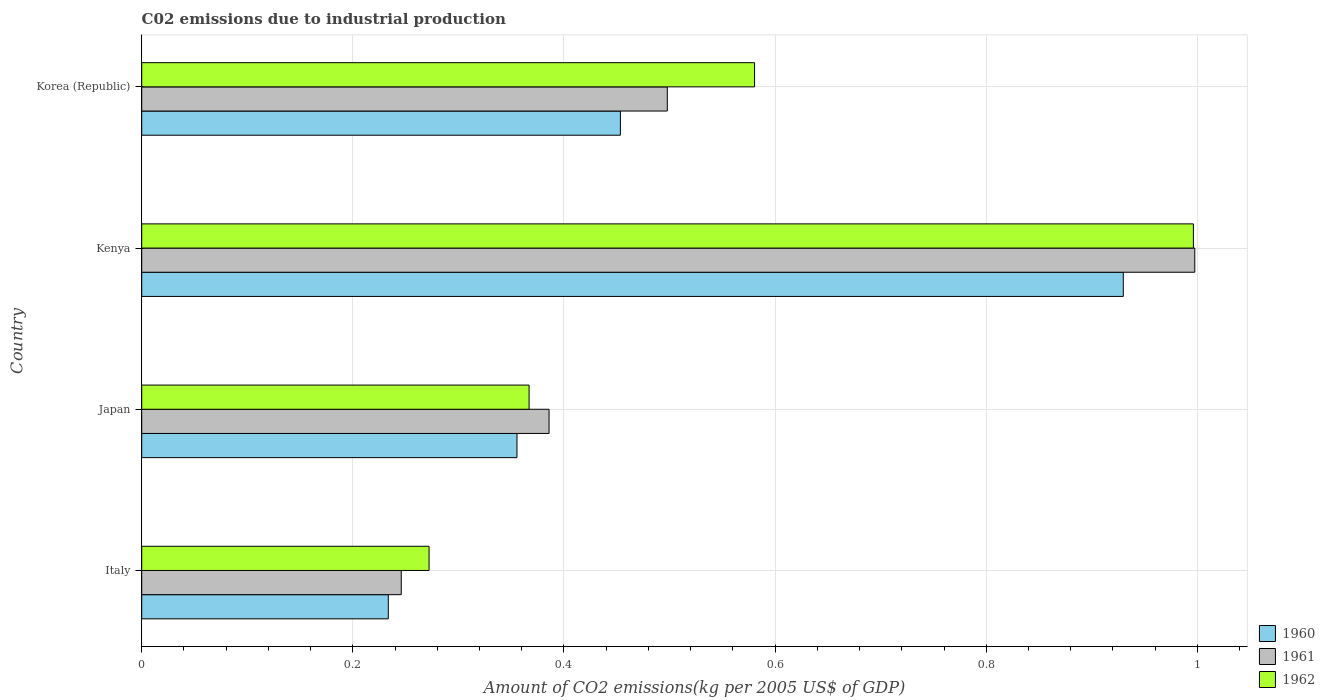How many different coloured bars are there?
Ensure brevity in your answer.  3. What is the label of the 2nd group of bars from the top?
Keep it short and to the point. Kenya. In how many cases, is the number of bars for a given country not equal to the number of legend labels?
Your answer should be compact. 0. What is the amount of CO2 emitted due to industrial production in 1961 in Italy?
Keep it short and to the point. 0.25. Across all countries, what is the maximum amount of CO2 emitted due to industrial production in 1961?
Your answer should be compact. 1. Across all countries, what is the minimum amount of CO2 emitted due to industrial production in 1961?
Offer a very short reply. 0.25. In which country was the amount of CO2 emitted due to industrial production in 1961 maximum?
Keep it short and to the point. Kenya. What is the total amount of CO2 emitted due to industrial production in 1960 in the graph?
Give a very brief answer. 1.97. What is the difference between the amount of CO2 emitted due to industrial production in 1960 in Italy and that in Kenya?
Keep it short and to the point. -0.7. What is the difference between the amount of CO2 emitted due to industrial production in 1962 in Japan and the amount of CO2 emitted due to industrial production in 1960 in Korea (Republic)?
Provide a succinct answer. -0.09. What is the average amount of CO2 emitted due to industrial production in 1961 per country?
Offer a terse response. 0.53. What is the difference between the amount of CO2 emitted due to industrial production in 1962 and amount of CO2 emitted due to industrial production in 1960 in Kenya?
Provide a succinct answer. 0.07. What is the ratio of the amount of CO2 emitted due to industrial production in 1960 in Italy to that in Kenya?
Keep it short and to the point. 0.25. What is the difference between the highest and the second highest amount of CO2 emitted due to industrial production in 1961?
Your response must be concise. 0.5. What is the difference between the highest and the lowest amount of CO2 emitted due to industrial production in 1961?
Ensure brevity in your answer.  0.75. Is the sum of the amount of CO2 emitted due to industrial production in 1960 in Italy and Kenya greater than the maximum amount of CO2 emitted due to industrial production in 1961 across all countries?
Your answer should be compact. Yes. What does the 1st bar from the top in Japan represents?
Make the answer very short. 1962. What does the 2nd bar from the bottom in Japan represents?
Make the answer very short. 1961. Is it the case that in every country, the sum of the amount of CO2 emitted due to industrial production in 1960 and amount of CO2 emitted due to industrial production in 1962 is greater than the amount of CO2 emitted due to industrial production in 1961?
Your response must be concise. Yes. How many countries are there in the graph?
Provide a short and direct response. 4. What is the difference between two consecutive major ticks on the X-axis?
Ensure brevity in your answer.  0.2. Does the graph contain any zero values?
Offer a terse response. No. Does the graph contain grids?
Provide a succinct answer. Yes. What is the title of the graph?
Provide a succinct answer. C02 emissions due to industrial production. Does "1988" appear as one of the legend labels in the graph?
Ensure brevity in your answer.  No. What is the label or title of the X-axis?
Provide a succinct answer. Amount of CO2 emissions(kg per 2005 US$ of GDP). What is the label or title of the Y-axis?
Make the answer very short. Country. What is the Amount of CO2 emissions(kg per 2005 US$ of GDP) in 1960 in Italy?
Keep it short and to the point. 0.23. What is the Amount of CO2 emissions(kg per 2005 US$ of GDP) in 1961 in Italy?
Make the answer very short. 0.25. What is the Amount of CO2 emissions(kg per 2005 US$ of GDP) of 1962 in Italy?
Provide a short and direct response. 0.27. What is the Amount of CO2 emissions(kg per 2005 US$ of GDP) of 1960 in Japan?
Provide a succinct answer. 0.36. What is the Amount of CO2 emissions(kg per 2005 US$ of GDP) in 1961 in Japan?
Make the answer very short. 0.39. What is the Amount of CO2 emissions(kg per 2005 US$ of GDP) of 1962 in Japan?
Offer a terse response. 0.37. What is the Amount of CO2 emissions(kg per 2005 US$ of GDP) in 1960 in Kenya?
Provide a short and direct response. 0.93. What is the Amount of CO2 emissions(kg per 2005 US$ of GDP) in 1961 in Kenya?
Provide a succinct answer. 1. What is the Amount of CO2 emissions(kg per 2005 US$ of GDP) in 1962 in Kenya?
Offer a very short reply. 1. What is the Amount of CO2 emissions(kg per 2005 US$ of GDP) of 1960 in Korea (Republic)?
Ensure brevity in your answer.  0.45. What is the Amount of CO2 emissions(kg per 2005 US$ of GDP) of 1961 in Korea (Republic)?
Your response must be concise. 0.5. What is the Amount of CO2 emissions(kg per 2005 US$ of GDP) of 1962 in Korea (Republic)?
Keep it short and to the point. 0.58. Across all countries, what is the maximum Amount of CO2 emissions(kg per 2005 US$ of GDP) of 1960?
Give a very brief answer. 0.93. Across all countries, what is the maximum Amount of CO2 emissions(kg per 2005 US$ of GDP) in 1961?
Your answer should be compact. 1. Across all countries, what is the maximum Amount of CO2 emissions(kg per 2005 US$ of GDP) in 1962?
Offer a very short reply. 1. Across all countries, what is the minimum Amount of CO2 emissions(kg per 2005 US$ of GDP) in 1960?
Your answer should be compact. 0.23. Across all countries, what is the minimum Amount of CO2 emissions(kg per 2005 US$ of GDP) of 1961?
Give a very brief answer. 0.25. Across all countries, what is the minimum Amount of CO2 emissions(kg per 2005 US$ of GDP) in 1962?
Your answer should be very brief. 0.27. What is the total Amount of CO2 emissions(kg per 2005 US$ of GDP) of 1960 in the graph?
Provide a short and direct response. 1.97. What is the total Amount of CO2 emissions(kg per 2005 US$ of GDP) in 1961 in the graph?
Make the answer very short. 2.13. What is the total Amount of CO2 emissions(kg per 2005 US$ of GDP) of 1962 in the graph?
Your response must be concise. 2.22. What is the difference between the Amount of CO2 emissions(kg per 2005 US$ of GDP) of 1960 in Italy and that in Japan?
Give a very brief answer. -0.12. What is the difference between the Amount of CO2 emissions(kg per 2005 US$ of GDP) of 1961 in Italy and that in Japan?
Your response must be concise. -0.14. What is the difference between the Amount of CO2 emissions(kg per 2005 US$ of GDP) in 1962 in Italy and that in Japan?
Make the answer very short. -0.09. What is the difference between the Amount of CO2 emissions(kg per 2005 US$ of GDP) of 1960 in Italy and that in Kenya?
Provide a succinct answer. -0.7. What is the difference between the Amount of CO2 emissions(kg per 2005 US$ of GDP) in 1961 in Italy and that in Kenya?
Offer a very short reply. -0.75. What is the difference between the Amount of CO2 emissions(kg per 2005 US$ of GDP) in 1962 in Italy and that in Kenya?
Your response must be concise. -0.72. What is the difference between the Amount of CO2 emissions(kg per 2005 US$ of GDP) of 1960 in Italy and that in Korea (Republic)?
Provide a succinct answer. -0.22. What is the difference between the Amount of CO2 emissions(kg per 2005 US$ of GDP) of 1961 in Italy and that in Korea (Republic)?
Keep it short and to the point. -0.25. What is the difference between the Amount of CO2 emissions(kg per 2005 US$ of GDP) of 1962 in Italy and that in Korea (Republic)?
Offer a very short reply. -0.31. What is the difference between the Amount of CO2 emissions(kg per 2005 US$ of GDP) in 1960 in Japan and that in Kenya?
Make the answer very short. -0.57. What is the difference between the Amount of CO2 emissions(kg per 2005 US$ of GDP) of 1961 in Japan and that in Kenya?
Your answer should be compact. -0.61. What is the difference between the Amount of CO2 emissions(kg per 2005 US$ of GDP) in 1962 in Japan and that in Kenya?
Your answer should be compact. -0.63. What is the difference between the Amount of CO2 emissions(kg per 2005 US$ of GDP) in 1960 in Japan and that in Korea (Republic)?
Make the answer very short. -0.1. What is the difference between the Amount of CO2 emissions(kg per 2005 US$ of GDP) in 1961 in Japan and that in Korea (Republic)?
Your answer should be very brief. -0.11. What is the difference between the Amount of CO2 emissions(kg per 2005 US$ of GDP) in 1962 in Japan and that in Korea (Republic)?
Provide a short and direct response. -0.21. What is the difference between the Amount of CO2 emissions(kg per 2005 US$ of GDP) of 1960 in Kenya and that in Korea (Republic)?
Your answer should be compact. 0.48. What is the difference between the Amount of CO2 emissions(kg per 2005 US$ of GDP) of 1961 in Kenya and that in Korea (Republic)?
Your response must be concise. 0.5. What is the difference between the Amount of CO2 emissions(kg per 2005 US$ of GDP) in 1962 in Kenya and that in Korea (Republic)?
Provide a succinct answer. 0.42. What is the difference between the Amount of CO2 emissions(kg per 2005 US$ of GDP) in 1960 in Italy and the Amount of CO2 emissions(kg per 2005 US$ of GDP) in 1961 in Japan?
Keep it short and to the point. -0.15. What is the difference between the Amount of CO2 emissions(kg per 2005 US$ of GDP) in 1960 in Italy and the Amount of CO2 emissions(kg per 2005 US$ of GDP) in 1962 in Japan?
Make the answer very short. -0.13. What is the difference between the Amount of CO2 emissions(kg per 2005 US$ of GDP) in 1961 in Italy and the Amount of CO2 emissions(kg per 2005 US$ of GDP) in 1962 in Japan?
Offer a terse response. -0.12. What is the difference between the Amount of CO2 emissions(kg per 2005 US$ of GDP) in 1960 in Italy and the Amount of CO2 emissions(kg per 2005 US$ of GDP) in 1961 in Kenya?
Your answer should be compact. -0.76. What is the difference between the Amount of CO2 emissions(kg per 2005 US$ of GDP) in 1960 in Italy and the Amount of CO2 emissions(kg per 2005 US$ of GDP) in 1962 in Kenya?
Your response must be concise. -0.76. What is the difference between the Amount of CO2 emissions(kg per 2005 US$ of GDP) in 1961 in Italy and the Amount of CO2 emissions(kg per 2005 US$ of GDP) in 1962 in Kenya?
Give a very brief answer. -0.75. What is the difference between the Amount of CO2 emissions(kg per 2005 US$ of GDP) of 1960 in Italy and the Amount of CO2 emissions(kg per 2005 US$ of GDP) of 1961 in Korea (Republic)?
Offer a very short reply. -0.26. What is the difference between the Amount of CO2 emissions(kg per 2005 US$ of GDP) in 1960 in Italy and the Amount of CO2 emissions(kg per 2005 US$ of GDP) in 1962 in Korea (Republic)?
Provide a succinct answer. -0.35. What is the difference between the Amount of CO2 emissions(kg per 2005 US$ of GDP) in 1961 in Italy and the Amount of CO2 emissions(kg per 2005 US$ of GDP) in 1962 in Korea (Republic)?
Provide a succinct answer. -0.33. What is the difference between the Amount of CO2 emissions(kg per 2005 US$ of GDP) in 1960 in Japan and the Amount of CO2 emissions(kg per 2005 US$ of GDP) in 1961 in Kenya?
Keep it short and to the point. -0.64. What is the difference between the Amount of CO2 emissions(kg per 2005 US$ of GDP) of 1960 in Japan and the Amount of CO2 emissions(kg per 2005 US$ of GDP) of 1962 in Kenya?
Your response must be concise. -0.64. What is the difference between the Amount of CO2 emissions(kg per 2005 US$ of GDP) in 1961 in Japan and the Amount of CO2 emissions(kg per 2005 US$ of GDP) in 1962 in Kenya?
Provide a short and direct response. -0.61. What is the difference between the Amount of CO2 emissions(kg per 2005 US$ of GDP) of 1960 in Japan and the Amount of CO2 emissions(kg per 2005 US$ of GDP) of 1961 in Korea (Republic)?
Keep it short and to the point. -0.14. What is the difference between the Amount of CO2 emissions(kg per 2005 US$ of GDP) in 1960 in Japan and the Amount of CO2 emissions(kg per 2005 US$ of GDP) in 1962 in Korea (Republic)?
Provide a succinct answer. -0.23. What is the difference between the Amount of CO2 emissions(kg per 2005 US$ of GDP) in 1961 in Japan and the Amount of CO2 emissions(kg per 2005 US$ of GDP) in 1962 in Korea (Republic)?
Your response must be concise. -0.19. What is the difference between the Amount of CO2 emissions(kg per 2005 US$ of GDP) in 1960 in Kenya and the Amount of CO2 emissions(kg per 2005 US$ of GDP) in 1961 in Korea (Republic)?
Provide a succinct answer. 0.43. What is the difference between the Amount of CO2 emissions(kg per 2005 US$ of GDP) in 1960 in Kenya and the Amount of CO2 emissions(kg per 2005 US$ of GDP) in 1962 in Korea (Republic)?
Offer a terse response. 0.35. What is the difference between the Amount of CO2 emissions(kg per 2005 US$ of GDP) of 1961 in Kenya and the Amount of CO2 emissions(kg per 2005 US$ of GDP) of 1962 in Korea (Republic)?
Offer a terse response. 0.42. What is the average Amount of CO2 emissions(kg per 2005 US$ of GDP) of 1960 per country?
Provide a succinct answer. 0.49. What is the average Amount of CO2 emissions(kg per 2005 US$ of GDP) in 1961 per country?
Offer a very short reply. 0.53. What is the average Amount of CO2 emissions(kg per 2005 US$ of GDP) in 1962 per country?
Give a very brief answer. 0.55. What is the difference between the Amount of CO2 emissions(kg per 2005 US$ of GDP) of 1960 and Amount of CO2 emissions(kg per 2005 US$ of GDP) of 1961 in Italy?
Give a very brief answer. -0.01. What is the difference between the Amount of CO2 emissions(kg per 2005 US$ of GDP) of 1960 and Amount of CO2 emissions(kg per 2005 US$ of GDP) of 1962 in Italy?
Keep it short and to the point. -0.04. What is the difference between the Amount of CO2 emissions(kg per 2005 US$ of GDP) of 1961 and Amount of CO2 emissions(kg per 2005 US$ of GDP) of 1962 in Italy?
Ensure brevity in your answer.  -0.03. What is the difference between the Amount of CO2 emissions(kg per 2005 US$ of GDP) of 1960 and Amount of CO2 emissions(kg per 2005 US$ of GDP) of 1961 in Japan?
Provide a succinct answer. -0.03. What is the difference between the Amount of CO2 emissions(kg per 2005 US$ of GDP) of 1960 and Amount of CO2 emissions(kg per 2005 US$ of GDP) of 1962 in Japan?
Offer a very short reply. -0.01. What is the difference between the Amount of CO2 emissions(kg per 2005 US$ of GDP) of 1961 and Amount of CO2 emissions(kg per 2005 US$ of GDP) of 1962 in Japan?
Provide a short and direct response. 0.02. What is the difference between the Amount of CO2 emissions(kg per 2005 US$ of GDP) in 1960 and Amount of CO2 emissions(kg per 2005 US$ of GDP) in 1961 in Kenya?
Keep it short and to the point. -0.07. What is the difference between the Amount of CO2 emissions(kg per 2005 US$ of GDP) of 1960 and Amount of CO2 emissions(kg per 2005 US$ of GDP) of 1962 in Kenya?
Make the answer very short. -0.07. What is the difference between the Amount of CO2 emissions(kg per 2005 US$ of GDP) of 1961 and Amount of CO2 emissions(kg per 2005 US$ of GDP) of 1962 in Kenya?
Make the answer very short. 0. What is the difference between the Amount of CO2 emissions(kg per 2005 US$ of GDP) of 1960 and Amount of CO2 emissions(kg per 2005 US$ of GDP) of 1961 in Korea (Republic)?
Your answer should be very brief. -0.04. What is the difference between the Amount of CO2 emissions(kg per 2005 US$ of GDP) in 1960 and Amount of CO2 emissions(kg per 2005 US$ of GDP) in 1962 in Korea (Republic)?
Keep it short and to the point. -0.13. What is the difference between the Amount of CO2 emissions(kg per 2005 US$ of GDP) of 1961 and Amount of CO2 emissions(kg per 2005 US$ of GDP) of 1962 in Korea (Republic)?
Provide a succinct answer. -0.08. What is the ratio of the Amount of CO2 emissions(kg per 2005 US$ of GDP) of 1960 in Italy to that in Japan?
Provide a short and direct response. 0.66. What is the ratio of the Amount of CO2 emissions(kg per 2005 US$ of GDP) of 1961 in Italy to that in Japan?
Your answer should be very brief. 0.64. What is the ratio of the Amount of CO2 emissions(kg per 2005 US$ of GDP) of 1962 in Italy to that in Japan?
Offer a terse response. 0.74. What is the ratio of the Amount of CO2 emissions(kg per 2005 US$ of GDP) of 1960 in Italy to that in Kenya?
Ensure brevity in your answer.  0.25. What is the ratio of the Amount of CO2 emissions(kg per 2005 US$ of GDP) in 1961 in Italy to that in Kenya?
Offer a terse response. 0.25. What is the ratio of the Amount of CO2 emissions(kg per 2005 US$ of GDP) of 1962 in Italy to that in Kenya?
Provide a succinct answer. 0.27. What is the ratio of the Amount of CO2 emissions(kg per 2005 US$ of GDP) of 1960 in Italy to that in Korea (Republic)?
Your answer should be compact. 0.52. What is the ratio of the Amount of CO2 emissions(kg per 2005 US$ of GDP) in 1961 in Italy to that in Korea (Republic)?
Give a very brief answer. 0.49. What is the ratio of the Amount of CO2 emissions(kg per 2005 US$ of GDP) in 1962 in Italy to that in Korea (Republic)?
Your answer should be compact. 0.47. What is the ratio of the Amount of CO2 emissions(kg per 2005 US$ of GDP) of 1960 in Japan to that in Kenya?
Provide a succinct answer. 0.38. What is the ratio of the Amount of CO2 emissions(kg per 2005 US$ of GDP) of 1961 in Japan to that in Kenya?
Ensure brevity in your answer.  0.39. What is the ratio of the Amount of CO2 emissions(kg per 2005 US$ of GDP) of 1962 in Japan to that in Kenya?
Provide a succinct answer. 0.37. What is the ratio of the Amount of CO2 emissions(kg per 2005 US$ of GDP) of 1960 in Japan to that in Korea (Republic)?
Offer a terse response. 0.78. What is the ratio of the Amount of CO2 emissions(kg per 2005 US$ of GDP) in 1961 in Japan to that in Korea (Republic)?
Your answer should be very brief. 0.78. What is the ratio of the Amount of CO2 emissions(kg per 2005 US$ of GDP) of 1962 in Japan to that in Korea (Republic)?
Your response must be concise. 0.63. What is the ratio of the Amount of CO2 emissions(kg per 2005 US$ of GDP) in 1960 in Kenya to that in Korea (Republic)?
Ensure brevity in your answer.  2.05. What is the ratio of the Amount of CO2 emissions(kg per 2005 US$ of GDP) in 1961 in Kenya to that in Korea (Republic)?
Ensure brevity in your answer.  2. What is the ratio of the Amount of CO2 emissions(kg per 2005 US$ of GDP) in 1962 in Kenya to that in Korea (Republic)?
Provide a short and direct response. 1.72. What is the difference between the highest and the second highest Amount of CO2 emissions(kg per 2005 US$ of GDP) in 1960?
Your answer should be very brief. 0.48. What is the difference between the highest and the second highest Amount of CO2 emissions(kg per 2005 US$ of GDP) in 1961?
Ensure brevity in your answer.  0.5. What is the difference between the highest and the second highest Amount of CO2 emissions(kg per 2005 US$ of GDP) in 1962?
Provide a succinct answer. 0.42. What is the difference between the highest and the lowest Amount of CO2 emissions(kg per 2005 US$ of GDP) of 1960?
Your answer should be very brief. 0.7. What is the difference between the highest and the lowest Amount of CO2 emissions(kg per 2005 US$ of GDP) in 1961?
Your answer should be very brief. 0.75. What is the difference between the highest and the lowest Amount of CO2 emissions(kg per 2005 US$ of GDP) of 1962?
Keep it short and to the point. 0.72. 